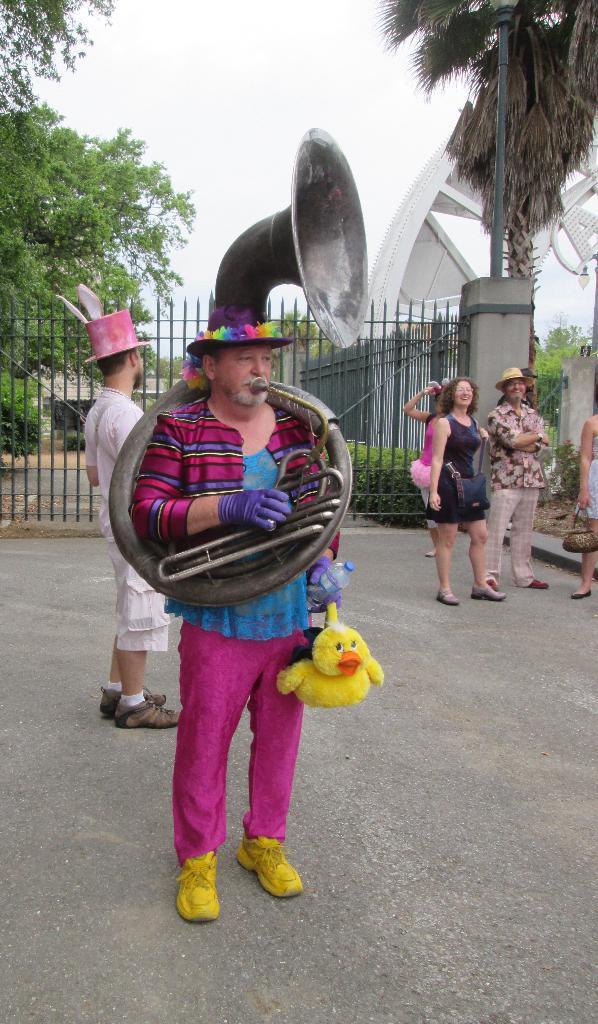Could you give a brief overview of what you see in this image? In this picture there is a man standing and playing musical instrument. At the back there are group of people standing and there is a railing and there is a street light and there are trees and there it looks like an arch and there is a building. At the top there is sky. At the bottom there are plants and there is a road. 